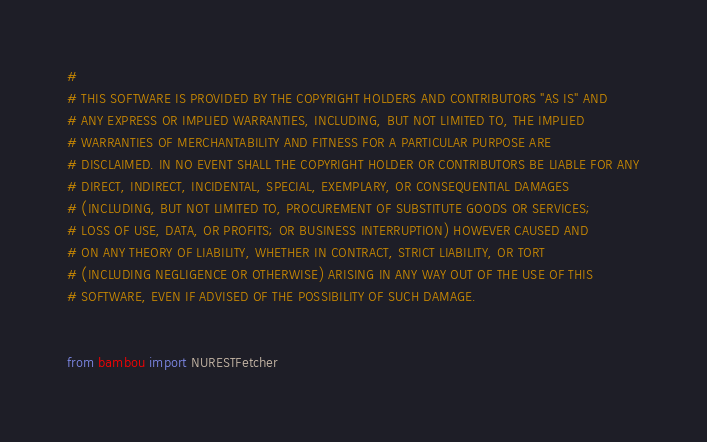Convert code to text. <code><loc_0><loc_0><loc_500><loc_500><_Python_>#
# THIS SOFTWARE IS PROVIDED BY THE COPYRIGHT HOLDERS AND CONTRIBUTORS "AS IS" AND
# ANY EXPRESS OR IMPLIED WARRANTIES, INCLUDING, BUT NOT LIMITED TO, THE IMPLIED
# WARRANTIES OF MERCHANTABILITY AND FITNESS FOR A PARTICULAR PURPOSE ARE
# DISCLAIMED. IN NO EVENT SHALL THE COPYRIGHT HOLDER OR CONTRIBUTORS BE LIABLE FOR ANY
# DIRECT, INDIRECT, INCIDENTAL, SPECIAL, EXEMPLARY, OR CONSEQUENTIAL DAMAGES
# (INCLUDING, BUT NOT LIMITED TO, PROCUREMENT OF SUBSTITUTE GOODS OR SERVICES;
# LOSS OF USE, DATA, OR PROFITS; OR BUSINESS INTERRUPTION) HOWEVER CAUSED AND
# ON ANY THEORY OF LIABILITY, WHETHER IN CONTRACT, STRICT LIABILITY, OR TORT
# (INCLUDING NEGLIGENCE OR OTHERWISE) ARISING IN ANY WAY OUT OF THE USE OF THIS
# SOFTWARE, EVEN IF ADVISED OF THE POSSIBILITY OF SUCH DAMAGE.


from bambou import NURESTFetcher

</code> 